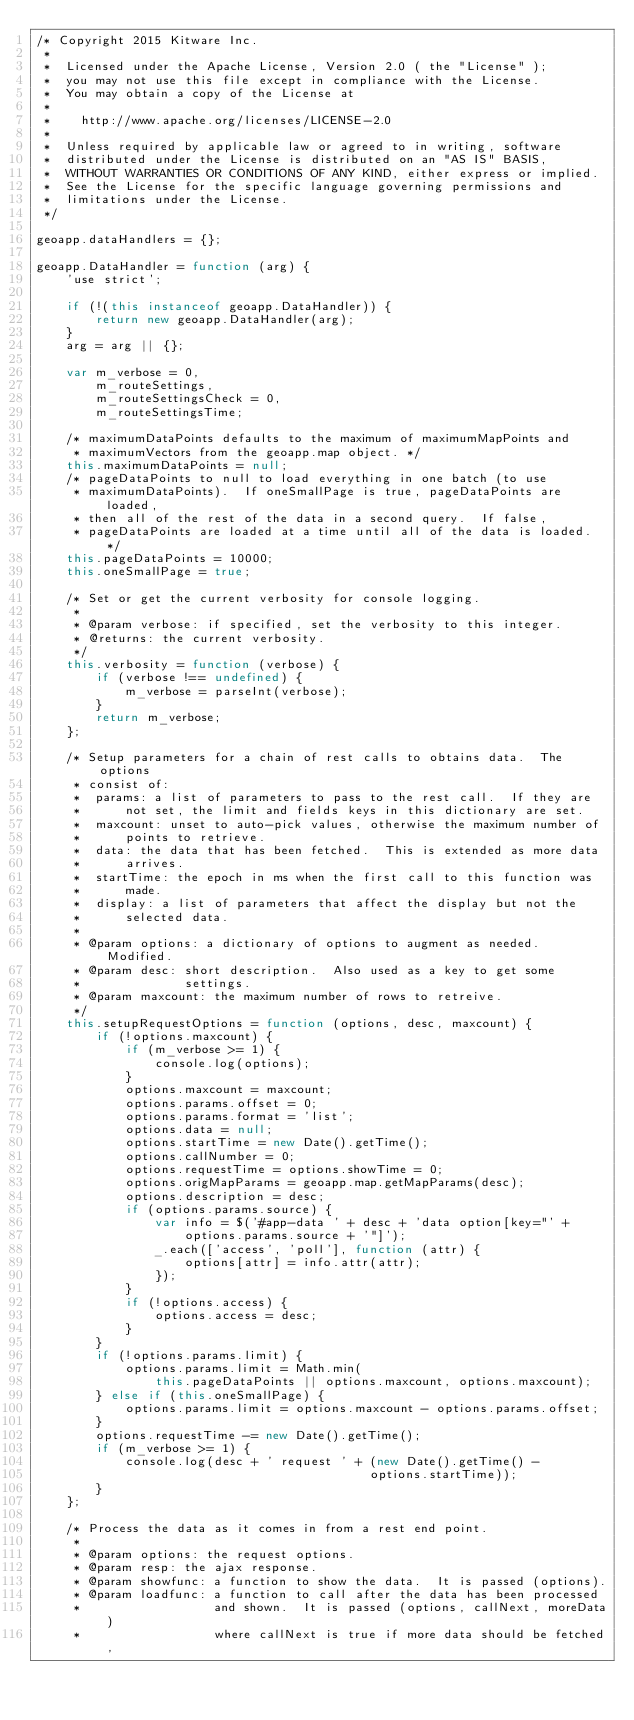Convert code to text. <code><loc_0><loc_0><loc_500><loc_500><_JavaScript_>/* Copyright 2015 Kitware Inc.
 *
 *  Licensed under the Apache License, Version 2.0 ( the "License" );
 *  you may not use this file except in compliance with the License.
 *  You may obtain a copy of the License at
 *
 *    http://www.apache.org/licenses/LICENSE-2.0
 *
 *  Unless required by applicable law or agreed to in writing, software
 *  distributed under the License is distributed on an "AS IS" BASIS,
 *  WITHOUT WARRANTIES OR CONDITIONS OF ANY KIND, either express or implied.
 *  See the License for the specific language governing permissions and
 *  limitations under the License.
 */

geoapp.dataHandlers = {};

geoapp.DataHandler = function (arg) {
    'use strict';

    if (!(this instanceof geoapp.DataHandler)) {
        return new geoapp.DataHandler(arg);
    }
    arg = arg || {};

    var m_verbose = 0,
        m_routeSettings,
        m_routeSettingsCheck = 0,
        m_routeSettingsTime;

    /* maximumDataPoints defaults to the maximum of maximumMapPoints and
     * maximumVectors from the geoapp.map object. */
    this.maximumDataPoints = null;
    /* pageDataPoints to null to load everything in one batch (to use
     * maximumDataPoints).  If oneSmallPage is true, pageDataPoints are loaded,
     * then all of the rest of the data in a second query.  If false,
     * pageDataPoints are loaded at a time until all of the data is loaded. */
    this.pageDataPoints = 10000;
    this.oneSmallPage = true;

    /* Set or get the current verbosity for console logging.
     *
     * @param verbose: if specified, set the verbosity to this integer.
     * @returns: the current verbosity.
     */
    this.verbosity = function (verbose) {
        if (verbose !== undefined) {
            m_verbose = parseInt(verbose);
        }
        return m_verbose;
    };

    /* Setup parameters for a chain of rest calls to obtains data.  The options
     * consist of:
     *  params: a list of parameters to pass to the rest call.  If they are
     *      not set, the limit and fields keys in this dictionary are set.
     *  maxcount: unset to auto-pick values, otherwise the maximum number of
     *      points to retrieve.
     *  data: the data that has been fetched.  This is extended as more data
     *      arrives.
     *  startTime: the epoch in ms when the first call to this function was
     *      made.
     *  display: a list of parameters that affect the display but not the
     *      selected data.
     *
     * @param options: a dictionary of options to augment as needed.  Modified.
     * @param desc: short description.  Also used as a key to get some
     *              settings.
     * @param maxcount: the maximum number of rows to retreive.
     */
    this.setupRequestOptions = function (options, desc, maxcount) {
        if (!options.maxcount) {
            if (m_verbose >= 1) {
                console.log(options);
            }
            options.maxcount = maxcount;
            options.params.offset = 0;
            options.params.format = 'list';
            options.data = null;
            options.startTime = new Date().getTime();
            options.callNumber = 0;
            options.requestTime = options.showTime = 0;
            options.origMapParams = geoapp.map.getMapParams(desc);
            options.description = desc;
            if (options.params.source) {
                var info = $('#app-data ' + desc + 'data option[key="' +
                    options.params.source + '"]');
                _.each(['access', 'poll'], function (attr) {
                    options[attr] = info.attr(attr);
                });
            }
            if (!options.access) {
                options.access = desc;
            }
        }
        if (!options.params.limit) {
            options.params.limit = Math.min(
                this.pageDataPoints || options.maxcount, options.maxcount);
        } else if (this.oneSmallPage) {
            options.params.limit = options.maxcount - options.params.offset;
        }
        options.requestTime -= new Date().getTime();
        if (m_verbose >= 1) {
            console.log(desc + ' request ' + (new Date().getTime() -
                                             options.startTime));
        }
    };

    /* Process the data as it comes in from a rest end point.
     *
     * @param options: the request options.
     * @param resp: the ajax response.
     * @param showfunc: a function to show the data.  It is passed (options).
     * @param loadfunc: a function to call after the data has been processed
     *                  and shown.  It is passed (options, callNext, moreData)
     *                  where callNext is true if more data should be fetched,</code> 